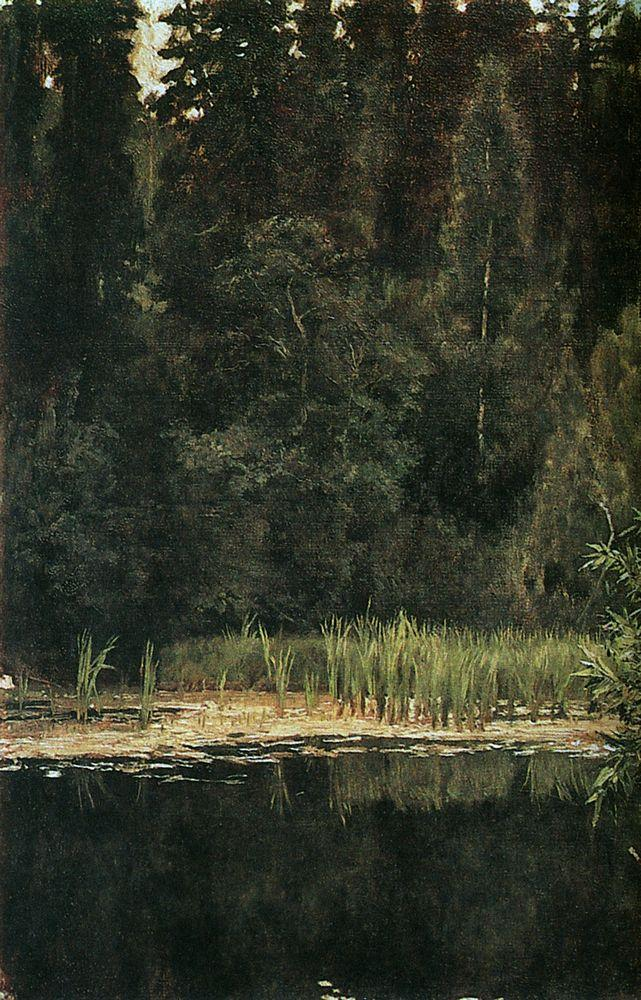Does this painting tell a story or convey a message? While there's no overt narrative in the painting, it holds an implied story in its serene stillness. One could interpret it as a moment of untouched wilderness, a snapshot of nature's solemn beauty. The way the light filters through the canopy and the stillness of the pond could symbolize a state of reflection or tranquility, suggesting a deeper message about finding peace in solitude and being in harmony with the natural world. 